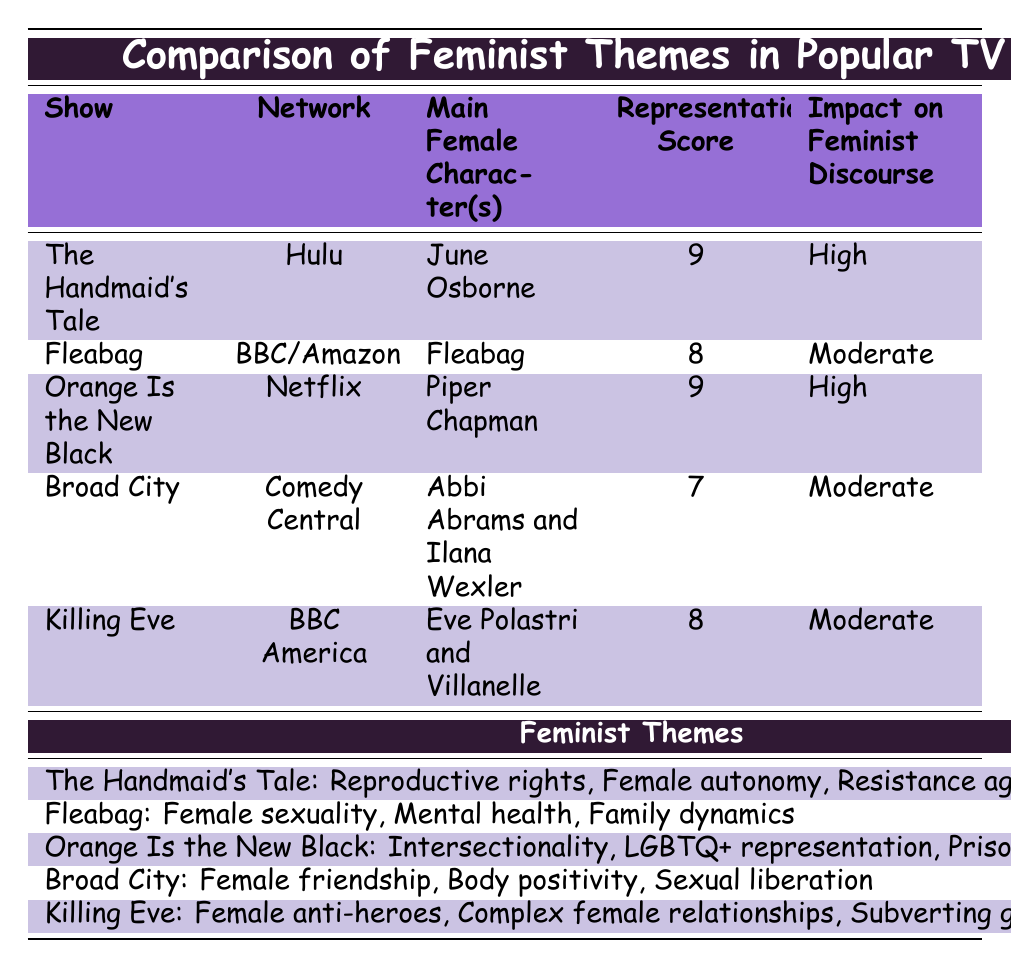What is the representation score of "Fleabag"? The table lists "Fleabag" under the representation score column, which shows a score of 8.
Answer: 8 What are the feminist themes highlighted in "Orange Is the New Black"? The table specifies the feminist themes for "Orange Is the New Black" as Intersectionality, LGBTQ+ representation, and Prison reform, which are listed in the corresponding row.
Answer: Intersectionality, LGBTQ+ representation, Prison reform Which show has the highest representation score? By inspecting the representation scores in the table, both "The Handmaid's Tale" and "Orange Is the New Black" have the highest score of 9, making them tied for the highest score.
Answer: The Handmaid's Tale and Orange Is the New Black Does "Killing Eve" mention body positivity as one of its feminist themes? Referring to the table, "Killing Eve" is listed with themes of Female anti-heroes, Complex female relationships, and Subverting gender roles, indicating that body positivity is not a theme here.
Answer: No What is the impact on feminist discourse for shows with a representation score of 9? Both "The Handmaid's Tale" and "Orange Is the New Black" are listed with a representation score of 9, and their corresponding impact on feminist discourse is labeled as High. Hence, the impact on feminist discourse for shows with this score is High.
Answer: High How many shows have a moderate impact on feminist discourse? The shows with a moderate impact on feminist discourse include "Fleabag," "Broad City," and "Killing Eve." Counting these gives us a total of 3 shows.
Answer: 3 Which show has explicit sexual content as a controversial element? The table indicates that "Fleabag" includes explicit sexual content under the controversial elements column, while other shows have different controversial themes noted.
Answer: Fleabag What themes are present in "Broad City"? According to the table, "Broad City" presents feminist themes of Female friendship, Body positivity, and Sexual liberation, as specifically mentioned in its respective row.
Answer: Female friendship, Body positivity, Sexual liberation How does the impact on feminist discourse vary between shows with scores of 7 and 9? The shows with a score of 7, such as "Broad City," have a moderate impact on feminist discourse, while shows with a score of 9, like "The Handmaid's Tale" and "Orange Is the New Black," exhibit a high impact. Thus, there is a difference in impact based on representation scores, showing that higher scores correlate with greater influence.
Answer: Shows with a score of 7 have a moderate impact while those with a score of 9 have a high impact 